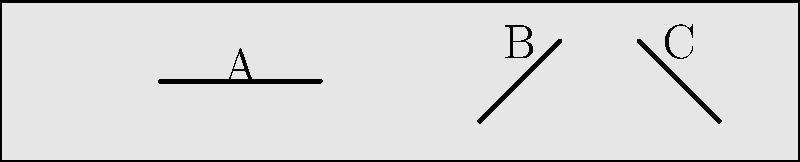Based on the tool marks shown on the fossilized bone fragment, which type of early human behavior is most likely represented? To determine the early human behavior represented by the tool marks, we need to analyze their characteristics:

1. Mark A: A straight, horizontal line, consistent with a cutting or slicing motion.
2. Mark B: An angled line, suggesting a more forceful, chopping action.
3. Mark C: Another angled line, similar to B, indicating a chopping or scraping motion.

Step-by-step analysis:
1. The presence of multiple marks indicates deliberate manipulation of the bone.
2. The variety in mark directions (horizontal and angled) suggests different tool uses.
3. The straight, horizontal mark (A) is typical of meat removal from bones.
4. The angled marks (B and C) are consistent with attempts to break the bone, possibly to access marrow.
5. The location and pattern of marks are indicative of systematic processing rather than random damage.

Considering these factors, the most likely early human behavior represented is butchery. This includes both meat removal (evidenced by the cutting mark) and marrow extraction (suggested by the chopping marks). Such activities are common in early human sites and indicate food processing behaviors.
Answer: Butchery 